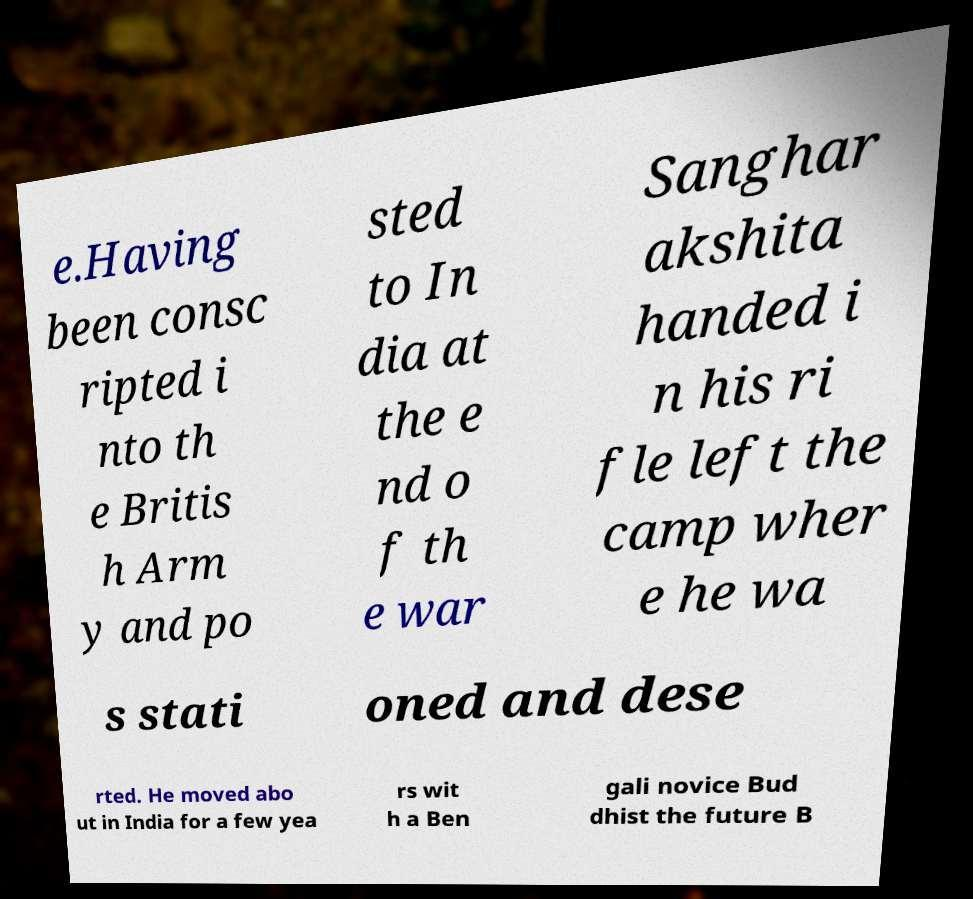Could you assist in decoding the text presented in this image and type it out clearly? e.Having been consc ripted i nto th e Britis h Arm y and po sted to In dia at the e nd o f th e war Sanghar akshita handed i n his ri fle left the camp wher e he wa s stati oned and dese rted. He moved abo ut in India for a few yea rs wit h a Ben gali novice Bud dhist the future B 